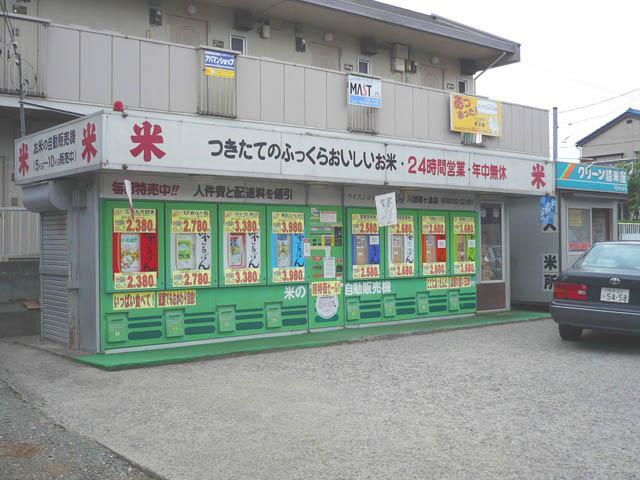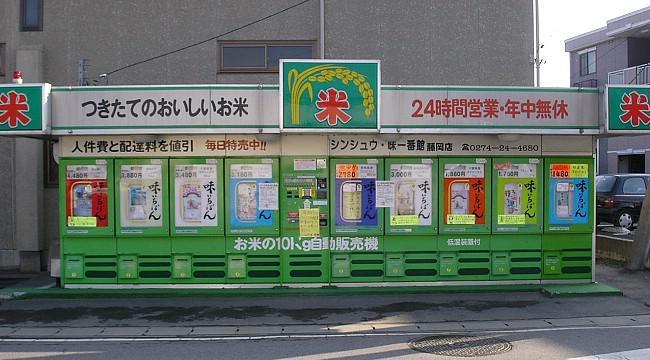The first image is the image on the left, the second image is the image on the right. Analyze the images presented: Is the assertion "One machine is cherry red." valid? Answer yes or no. No. 